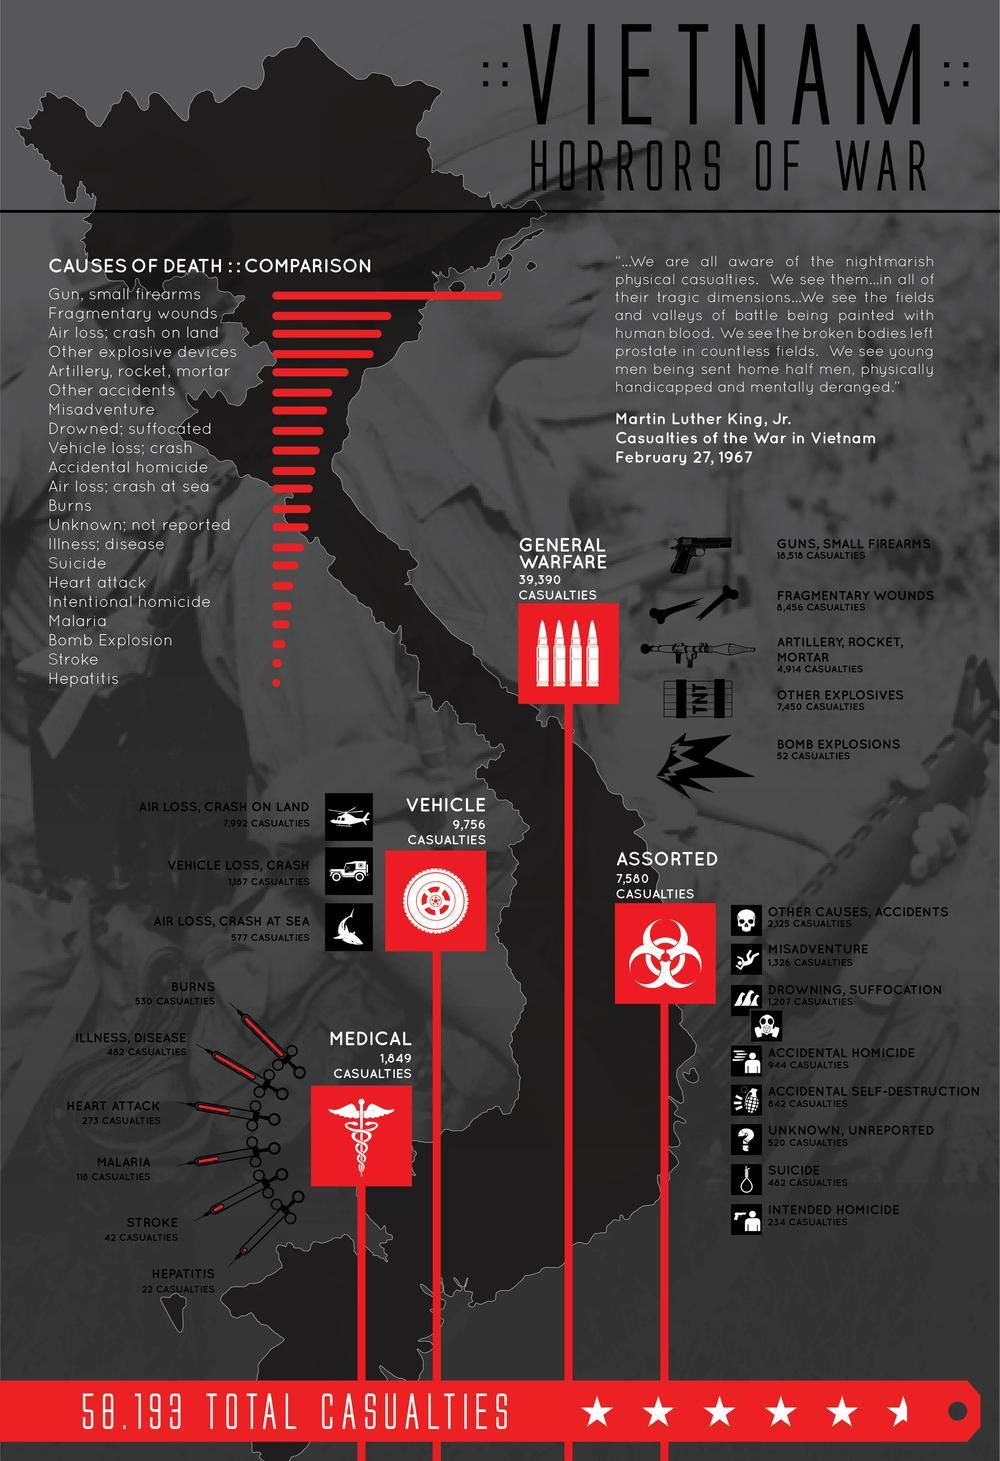How many casualties were assorted?
Answer the question with a short phrase. 7,580 casualties How many Casualties had Malaria, Stroke, and Hepatitis? 182 What is the seventh-most reason leading to the death of casualties in war? Misadventure What is the fifth-most reason leading to the death of casualties in war? Artillery, rocket, mortar How many casualties were there in the General Warfare? 39,390 casualties What is the third-least reason leading to the death of casualties in war? Bomb Explosion What is the second-most reason leading to the death of casualties in war? Fragmentary wounds How many Casualties required Medical attention? 1,849 casualties How many casualties were there in the Vehicle? 9,756 casualties How many Casualties were there in the Flight crash on Land and sea? 8,569 